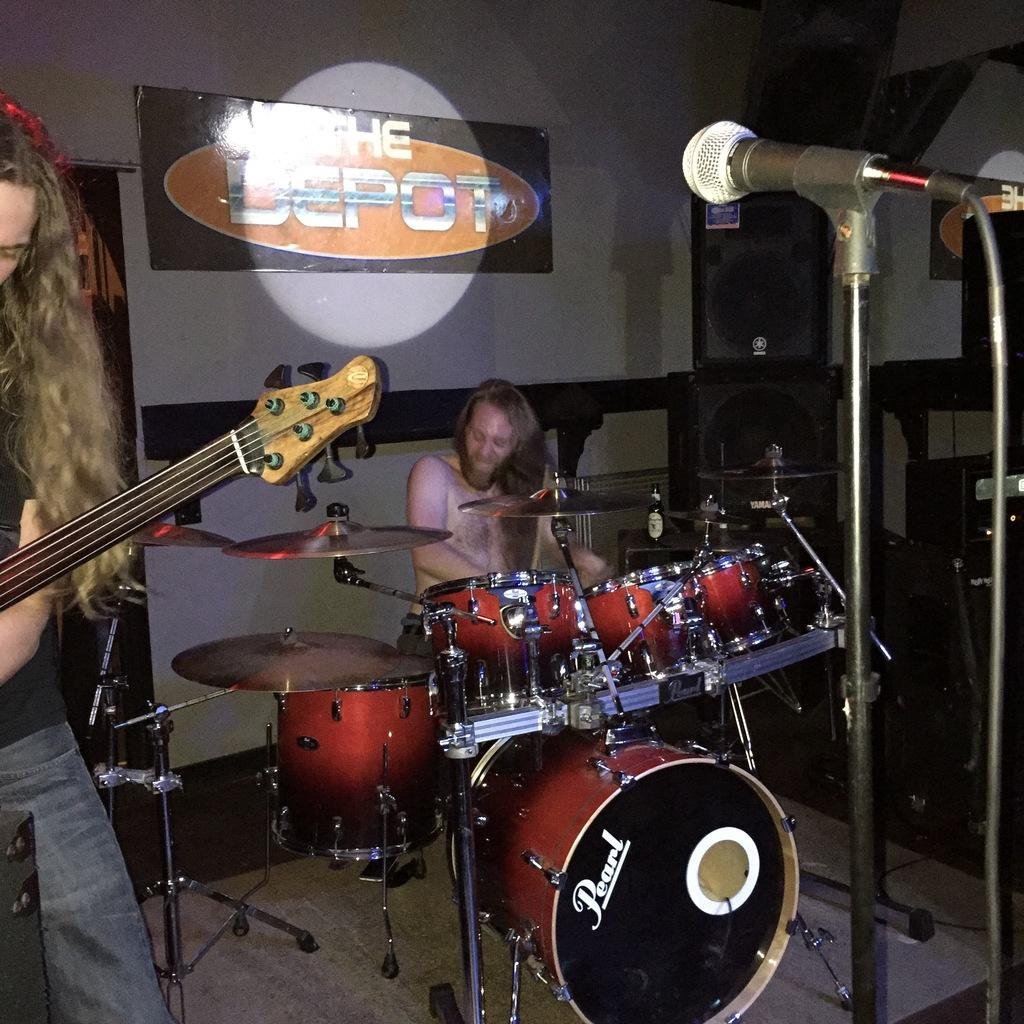How many people are in the image? There are two men in the image. What are the men doing in the image? One man is playing a guitar, and the other man is playing drums. What equipment is visible in front of the musicians? There are microphones in front of the musicians. What can be seen in the background of the image? There is a screen with a banner and speakers in the background. Can you tell me how many horses are present in the image? There are no horses present in the image. What type of worm can be seen crawling on the guitarist's hand in the image? There are no worms present in the image, and the guitarist's hands are not visible. 